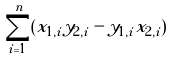Convert formula to latex. <formula><loc_0><loc_0><loc_500><loc_500>\sum _ { i = 1 } ^ { n } ( x _ { 1 , i } y _ { 2 , i } - y _ { 1 , i } x _ { 2 , i } )</formula> 